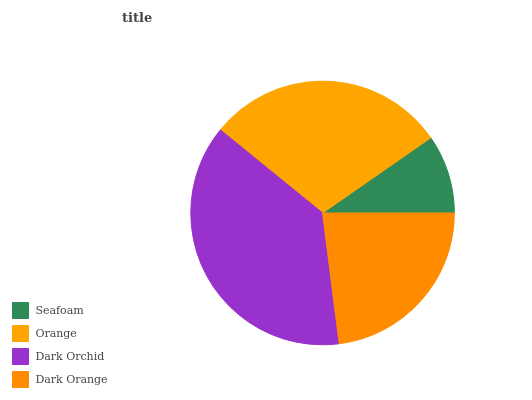Is Seafoam the minimum?
Answer yes or no. Yes. Is Dark Orchid the maximum?
Answer yes or no. Yes. Is Orange the minimum?
Answer yes or no. No. Is Orange the maximum?
Answer yes or no. No. Is Orange greater than Seafoam?
Answer yes or no. Yes. Is Seafoam less than Orange?
Answer yes or no. Yes. Is Seafoam greater than Orange?
Answer yes or no. No. Is Orange less than Seafoam?
Answer yes or no. No. Is Orange the high median?
Answer yes or no. Yes. Is Dark Orange the low median?
Answer yes or no. Yes. Is Dark Orange the high median?
Answer yes or no. No. Is Seafoam the low median?
Answer yes or no. No. 